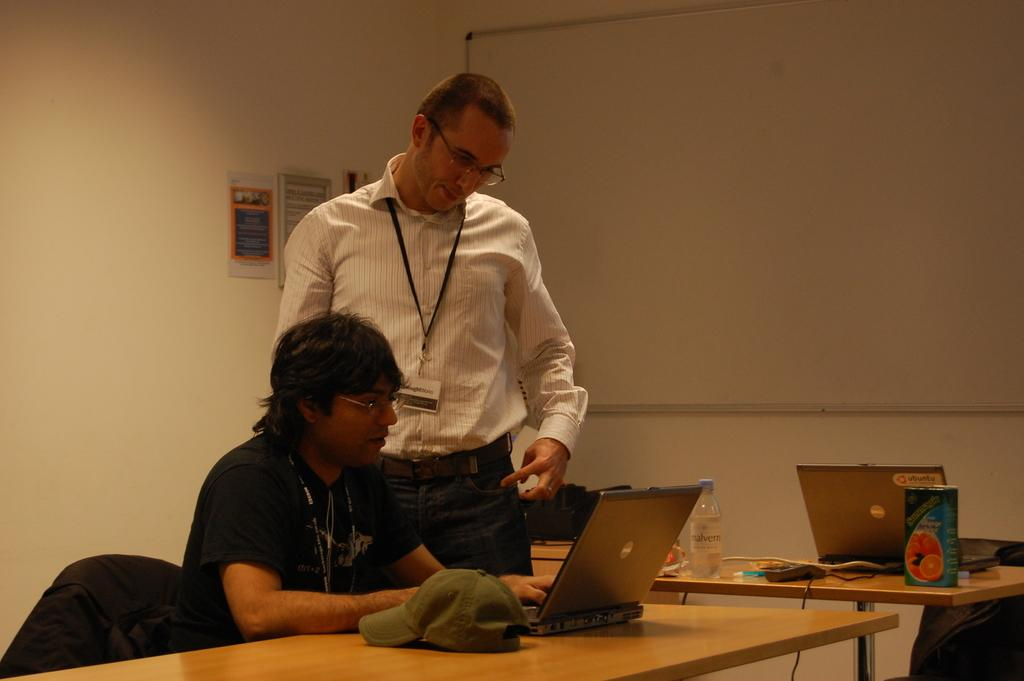What is in front of the person in the image? There is a table in front of the person. What can be seen on the table? There is a cap, laptops, a bottle, and a food packet on the table. What is on the wall in the image? There is a whiteboard on the wall. How does the person transport the laptops in the image? The image does not show the person transporting the laptops; they are stationary on the table. 